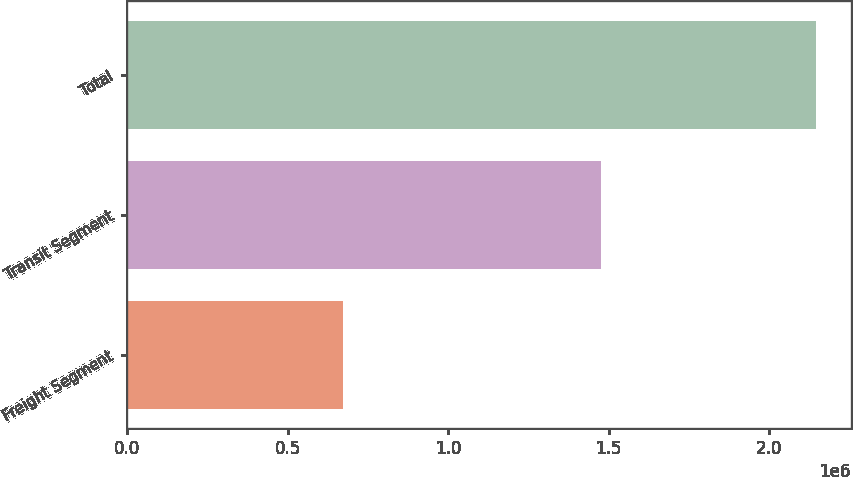Convert chart to OTSL. <chart><loc_0><loc_0><loc_500><loc_500><bar_chart><fcel>Freight Segment<fcel>Transit Segment<fcel>Total<nl><fcel>671910<fcel>1.47497e+06<fcel>2.14688e+06<nl></chart> 